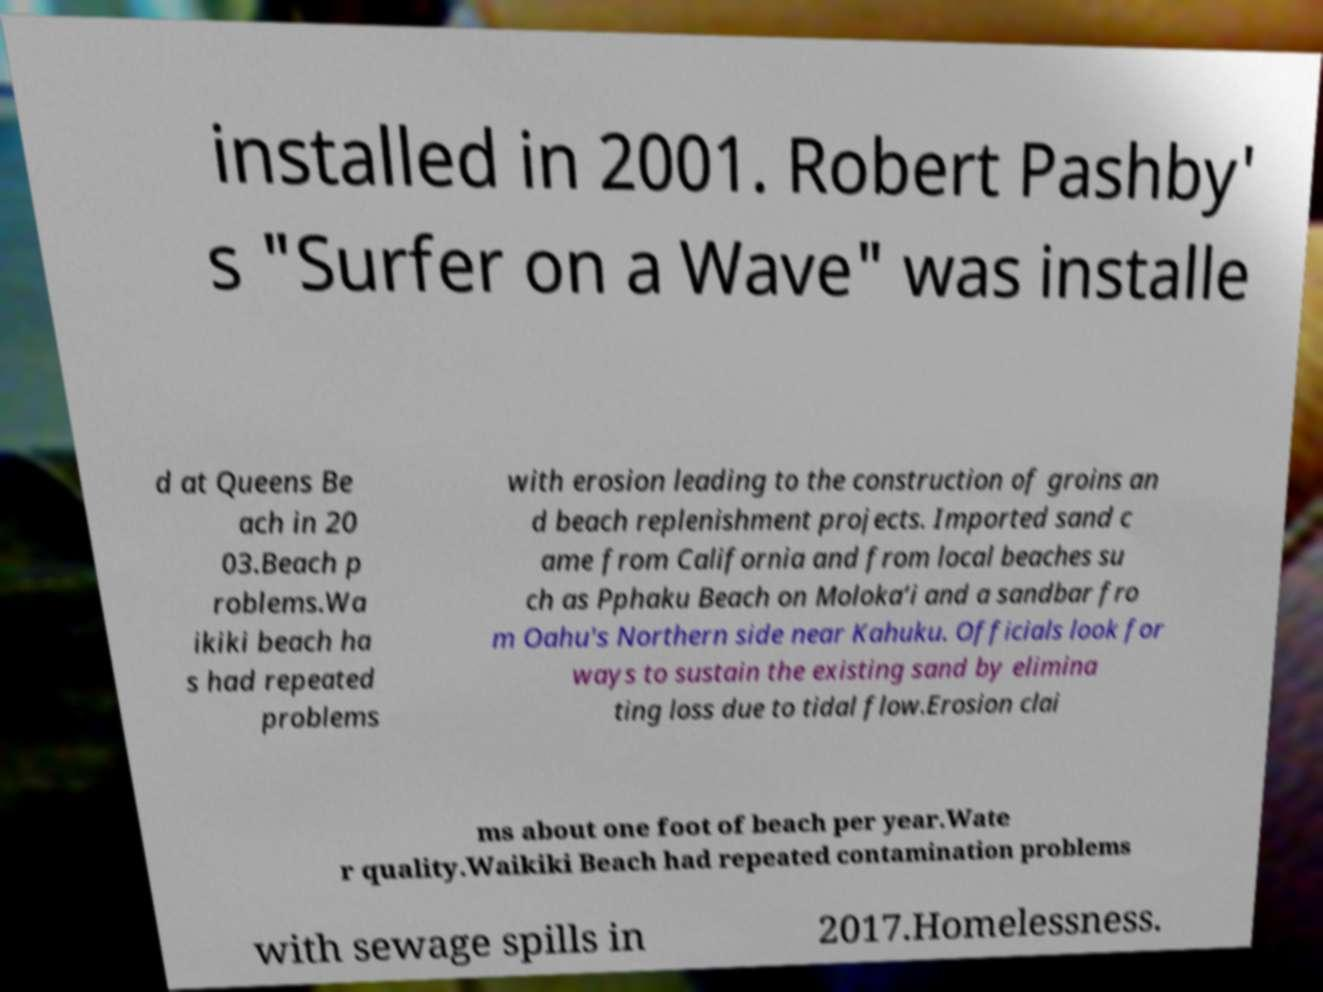Can you accurately transcribe the text from the provided image for me? installed in 2001. Robert Pashby' s "Surfer on a Wave" was installe d at Queens Be ach in 20 03.Beach p roblems.Wa ikiki beach ha s had repeated problems with erosion leading to the construction of groins an d beach replenishment projects. Imported sand c ame from California and from local beaches su ch as Pphaku Beach on Moloka‘i and a sandbar fro m Oahu's Northern side near Kahuku. Officials look for ways to sustain the existing sand by elimina ting loss due to tidal flow.Erosion clai ms about one foot of beach per year.Wate r quality.Waikiki Beach had repeated contamination problems with sewage spills in 2017.Homelessness. 